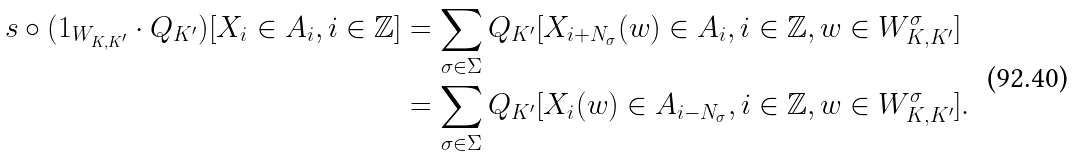<formula> <loc_0><loc_0><loc_500><loc_500>s \circ ( 1 _ { W _ { K , K ^ { \prime } } } \cdot Q _ { K ^ { \prime } } ) [ X _ { i } \in A _ { i } , i \in \mathbb { Z } ] & = \sum _ { \sigma \in \Sigma } Q _ { K ^ { \prime } } [ X _ { i + N _ { \sigma } } ( w ) \in A _ { i } , i \in \mathbb { Z } , w \in W _ { K , K ^ { \prime } } ^ { \sigma } ] \\ & = \sum _ { \sigma \in \Sigma } Q _ { K ^ { \prime } } [ X _ { i } ( w ) \in A _ { i - N _ { \sigma } } , i \in \mathbb { Z } , w \in W _ { K , K ^ { \prime } } ^ { \sigma } ] .</formula> 